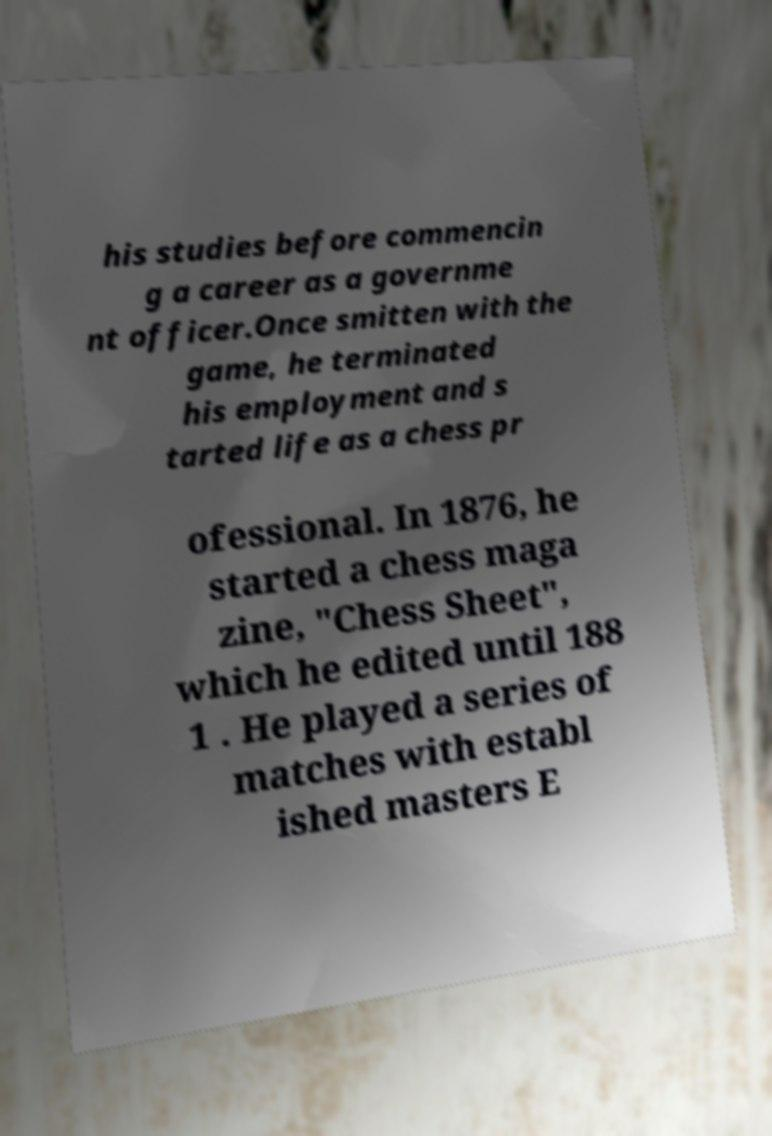Please identify and transcribe the text found in this image. his studies before commencin g a career as a governme nt officer.Once smitten with the game, he terminated his employment and s tarted life as a chess pr ofessional. In 1876, he started a chess maga zine, "Chess Sheet", which he edited until 188 1 . He played a series of matches with establ ished masters E 